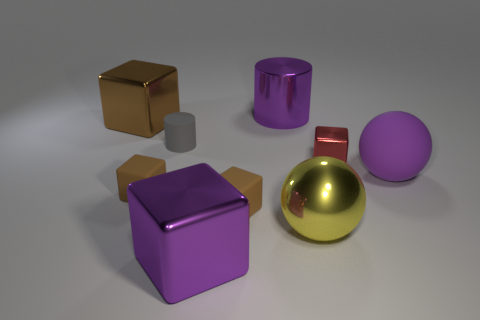There is a small cylinder that is the same material as the large purple sphere; what color is it?
Provide a succinct answer. Gray. Is the number of large yellow metal balls less than the number of tiny blue matte blocks?
Keep it short and to the point. No. What is the material of the small cube that is both right of the tiny cylinder and in front of the small red metal object?
Ensure brevity in your answer.  Rubber. Are there any large purple metal blocks that are behind the purple object on the left side of the shiny cylinder?
Your answer should be compact. No. How many balls have the same color as the big cylinder?
Offer a terse response. 1. There is a big cube that is the same color as the big rubber object; what is it made of?
Your response must be concise. Metal. Are the large purple cylinder and the gray thing made of the same material?
Provide a succinct answer. No. Are there any brown matte cubes to the right of the brown shiny thing?
Offer a very short reply. Yes. What material is the cylinder that is behind the large metal cube behind the purple matte object made of?
Offer a very short reply. Metal. What size is the yellow thing that is the same shape as the purple rubber object?
Make the answer very short. Large. 